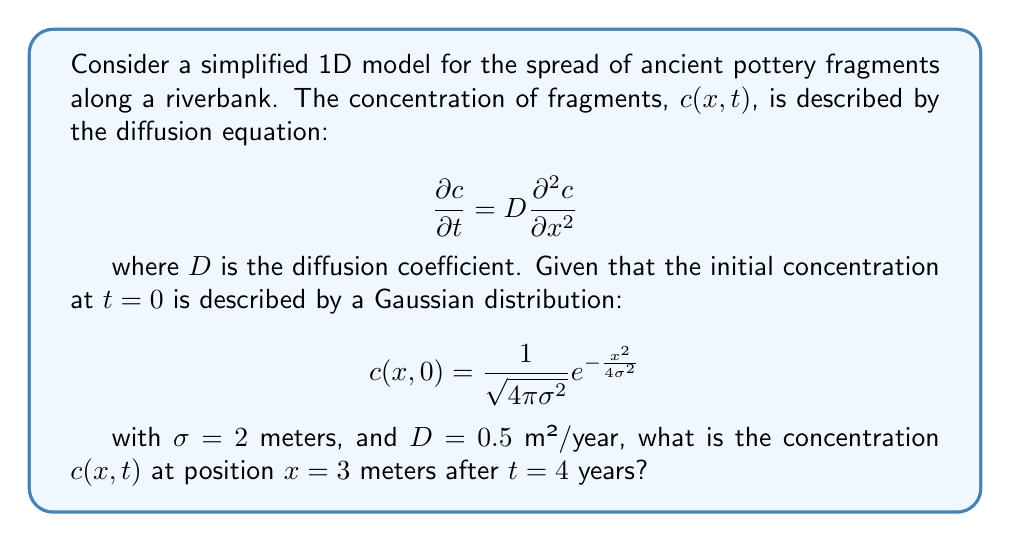What is the answer to this math problem? To solve this problem, we need to use the solution to the diffusion equation with a Gaussian initial condition. The general solution is:

$$c(x,t) = \frac{1}{\sqrt{4\pi(\sigma^2 + Dt)}}e^{-\frac{x^2}{4(\sigma^2 + Dt)}}$$

Let's follow these steps:

1) First, we need to substitute the given values:
   $\sigma = 2$ m
   $D = 0.5$ m²/year
   $x = 3$ m
   $t = 4$ years

2) Calculate $\sigma^2 + Dt$:
   $\sigma^2 + Dt = 2^2 + 0.5 \cdot 4 = 4 + 2 = 6$ m²

3) Now we can substitute these values into the solution equation:

   $$c(3,4) = \frac{1}{\sqrt{4\pi(6)}}e^{-\frac{3^2}{4(6)}}$$

4) Simplify:
   $$c(3,4) = \frac{1}{\sqrt{24\pi}}e^{-\frac{9}{24}}$$

5) Calculate:
   $$c(3,4) = \frac{1}{\sqrt{24\pi}} \cdot e^{-0.375} \approx 0.0398$$

Therefore, the concentration at $x = 3$ meters after $t = 4$ years is approximately 0.0398 fragments per meter.
Answer: $c(3,4) \approx 0.0398$ fragments/m 